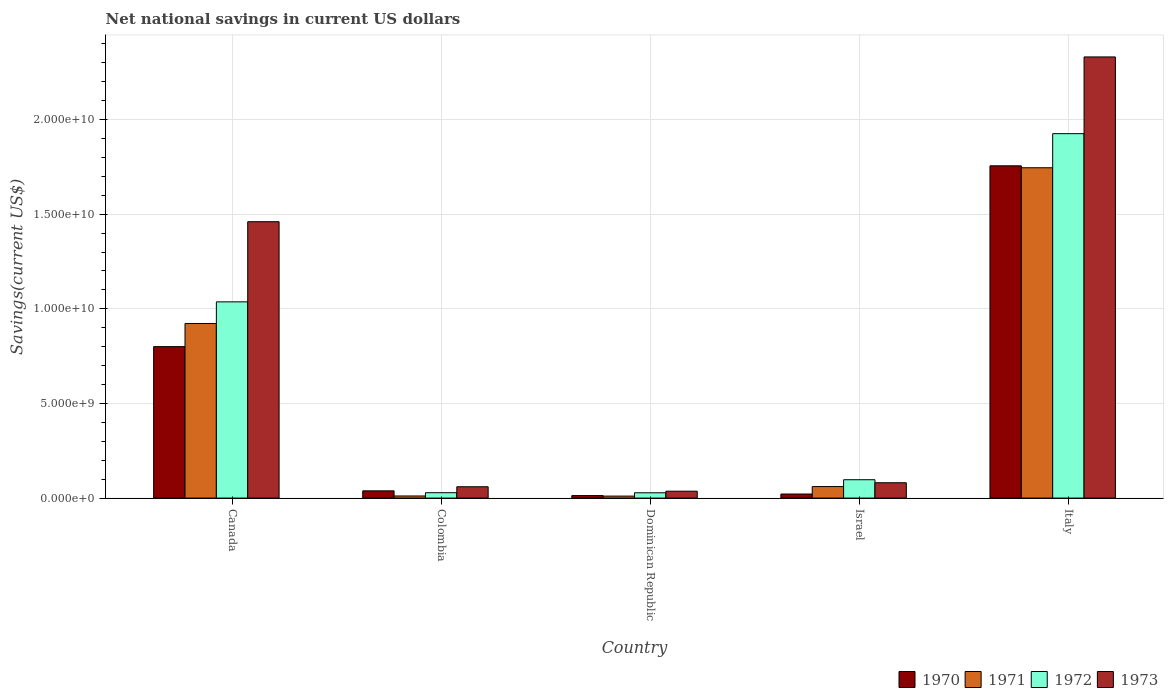How many different coloured bars are there?
Provide a short and direct response. 4. How many groups of bars are there?
Give a very brief answer. 5. Are the number of bars per tick equal to the number of legend labels?
Provide a short and direct response. Yes. How many bars are there on the 1st tick from the left?
Your response must be concise. 4. What is the label of the 4th group of bars from the left?
Make the answer very short. Israel. In how many cases, is the number of bars for a given country not equal to the number of legend labels?
Offer a terse response. 0. What is the net national savings in 1970 in Canada?
Your answer should be compact. 8.00e+09. Across all countries, what is the maximum net national savings in 1972?
Keep it short and to the point. 1.93e+1. Across all countries, what is the minimum net national savings in 1972?
Provide a short and direct response. 2.80e+08. In which country was the net national savings in 1971 maximum?
Your response must be concise. Italy. In which country was the net national savings in 1972 minimum?
Make the answer very short. Dominican Republic. What is the total net national savings in 1973 in the graph?
Your answer should be very brief. 3.97e+1. What is the difference between the net national savings in 1972 in Colombia and that in Dominican Republic?
Your response must be concise. 3.48e+06. What is the difference between the net national savings in 1972 in Colombia and the net national savings in 1970 in Italy?
Provide a short and direct response. -1.73e+1. What is the average net national savings in 1973 per country?
Offer a terse response. 7.94e+09. What is the difference between the net national savings of/in 1973 and net national savings of/in 1970 in Canada?
Ensure brevity in your answer.  6.60e+09. What is the ratio of the net national savings in 1971 in Dominican Republic to that in Italy?
Provide a succinct answer. 0.01. What is the difference between the highest and the second highest net national savings in 1972?
Offer a terse response. -1.83e+1. What is the difference between the highest and the lowest net national savings in 1970?
Ensure brevity in your answer.  1.74e+1. Is it the case that in every country, the sum of the net national savings in 1970 and net national savings in 1971 is greater than the sum of net national savings in 1972 and net national savings in 1973?
Provide a short and direct response. No. What does the 1st bar from the left in Dominican Republic represents?
Provide a succinct answer. 1970. Are the values on the major ticks of Y-axis written in scientific E-notation?
Your answer should be very brief. Yes. Does the graph contain grids?
Provide a succinct answer. Yes. Where does the legend appear in the graph?
Your answer should be very brief. Bottom right. How are the legend labels stacked?
Offer a terse response. Horizontal. What is the title of the graph?
Ensure brevity in your answer.  Net national savings in current US dollars. What is the label or title of the Y-axis?
Provide a succinct answer. Savings(current US$). What is the Savings(current US$) in 1970 in Canada?
Offer a terse response. 8.00e+09. What is the Savings(current US$) in 1971 in Canada?
Your answer should be very brief. 9.23e+09. What is the Savings(current US$) in 1972 in Canada?
Provide a succinct answer. 1.04e+1. What is the Savings(current US$) of 1973 in Canada?
Provide a succinct answer. 1.46e+1. What is the Savings(current US$) of 1970 in Colombia?
Your answer should be compact. 3.83e+08. What is the Savings(current US$) in 1971 in Colombia?
Ensure brevity in your answer.  1.11e+08. What is the Savings(current US$) of 1972 in Colombia?
Keep it short and to the point. 2.84e+08. What is the Savings(current US$) of 1973 in Colombia?
Your answer should be very brief. 5.98e+08. What is the Savings(current US$) in 1970 in Dominican Republic?
Your response must be concise. 1.33e+08. What is the Savings(current US$) in 1971 in Dominican Republic?
Provide a succinct answer. 1.05e+08. What is the Savings(current US$) of 1972 in Dominican Republic?
Your response must be concise. 2.80e+08. What is the Savings(current US$) in 1973 in Dominican Republic?
Keep it short and to the point. 3.65e+08. What is the Savings(current US$) of 1970 in Israel?
Keep it short and to the point. 2.15e+08. What is the Savings(current US$) of 1971 in Israel?
Keep it short and to the point. 6.09e+08. What is the Savings(current US$) of 1972 in Israel?
Make the answer very short. 9.71e+08. What is the Savings(current US$) of 1973 in Israel?
Your response must be concise. 8.11e+08. What is the Savings(current US$) in 1970 in Italy?
Provide a short and direct response. 1.76e+1. What is the Savings(current US$) of 1971 in Italy?
Give a very brief answer. 1.75e+1. What is the Savings(current US$) in 1972 in Italy?
Provide a succinct answer. 1.93e+1. What is the Savings(current US$) of 1973 in Italy?
Give a very brief answer. 2.33e+1. Across all countries, what is the maximum Savings(current US$) of 1970?
Offer a very short reply. 1.76e+1. Across all countries, what is the maximum Savings(current US$) in 1971?
Make the answer very short. 1.75e+1. Across all countries, what is the maximum Savings(current US$) in 1972?
Make the answer very short. 1.93e+1. Across all countries, what is the maximum Savings(current US$) in 1973?
Offer a very short reply. 2.33e+1. Across all countries, what is the minimum Savings(current US$) in 1970?
Your answer should be very brief. 1.33e+08. Across all countries, what is the minimum Savings(current US$) of 1971?
Your answer should be very brief. 1.05e+08. Across all countries, what is the minimum Savings(current US$) of 1972?
Keep it short and to the point. 2.80e+08. Across all countries, what is the minimum Savings(current US$) in 1973?
Provide a succinct answer. 3.65e+08. What is the total Savings(current US$) of 1970 in the graph?
Give a very brief answer. 2.63e+1. What is the total Savings(current US$) of 1971 in the graph?
Provide a succinct answer. 2.75e+1. What is the total Savings(current US$) of 1972 in the graph?
Your response must be concise. 3.12e+1. What is the total Savings(current US$) in 1973 in the graph?
Your answer should be very brief. 3.97e+1. What is the difference between the Savings(current US$) in 1970 in Canada and that in Colombia?
Your answer should be compact. 7.62e+09. What is the difference between the Savings(current US$) of 1971 in Canada and that in Colombia?
Provide a succinct answer. 9.11e+09. What is the difference between the Savings(current US$) in 1972 in Canada and that in Colombia?
Make the answer very short. 1.01e+1. What is the difference between the Savings(current US$) in 1973 in Canada and that in Colombia?
Ensure brevity in your answer.  1.40e+1. What is the difference between the Savings(current US$) of 1970 in Canada and that in Dominican Republic?
Ensure brevity in your answer.  7.87e+09. What is the difference between the Savings(current US$) of 1971 in Canada and that in Dominican Republic?
Provide a succinct answer. 9.12e+09. What is the difference between the Savings(current US$) in 1972 in Canada and that in Dominican Republic?
Provide a succinct answer. 1.01e+1. What is the difference between the Savings(current US$) of 1973 in Canada and that in Dominican Republic?
Your answer should be compact. 1.42e+1. What is the difference between the Savings(current US$) of 1970 in Canada and that in Israel?
Your response must be concise. 7.79e+09. What is the difference between the Savings(current US$) in 1971 in Canada and that in Israel?
Offer a very short reply. 8.62e+09. What is the difference between the Savings(current US$) of 1972 in Canada and that in Israel?
Provide a succinct answer. 9.40e+09. What is the difference between the Savings(current US$) of 1973 in Canada and that in Israel?
Your answer should be very brief. 1.38e+1. What is the difference between the Savings(current US$) in 1970 in Canada and that in Italy?
Make the answer very short. -9.55e+09. What is the difference between the Savings(current US$) in 1971 in Canada and that in Italy?
Provide a succinct answer. -8.23e+09. What is the difference between the Savings(current US$) of 1972 in Canada and that in Italy?
Make the answer very short. -8.89e+09. What is the difference between the Savings(current US$) of 1973 in Canada and that in Italy?
Your answer should be very brief. -8.71e+09. What is the difference between the Savings(current US$) in 1970 in Colombia and that in Dominican Republic?
Ensure brevity in your answer.  2.50e+08. What is the difference between the Savings(current US$) in 1971 in Colombia and that in Dominican Republic?
Your answer should be very brief. 6.03e+06. What is the difference between the Savings(current US$) of 1972 in Colombia and that in Dominican Republic?
Offer a terse response. 3.48e+06. What is the difference between the Savings(current US$) in 1973 in Colombia and that in Dominican Republic?
Provide a succinct answer. 2.34e+08. What is the difference between the Savings(current US$) of 1970 in Colombia and that in Israel?
Keep it short and to the point. 1.68e+08. What is the difference between the Savings(current US$) of 1971 in Colombia and that in Israel?
Offer a terse response. -4.97e+08. What is the difference between the Savings(current US$) in 1972 in Colombia and that in Israel?
Your response must be concise. -6.87e+08. What is the difference between the Savings(current US$) of 1973 in Colombia and that in Israel?
Provide a short and direct response. -2.12e+08. What is the difference between the Savings(current US$) in 1970 in Colombia and that in Italy?
Give a very brief answer. -1.72e+1. What is the difference between the Savings(current US$) in 1971 in Colombia and that in Italy?
Offer a very short reply. -1.73e+1. What is the difference between the Savings(current US$) of 1972 in Colombia and that in Italy?
Your response must be concise. -1.90e+1. What is the difference between the Savings(current US$) in 1973 in Colombia and that in Italy?
Offer a very short reply. -2.27e+1. What is the difference between the Savings(current US$) of 1970 in Dominican Republic and that in Israel?
Provide a short and direct response. -8.19e+07. What is the difference between the Savings(current US$) in 1971 in Dominican Republic and that in Israel?
Ensure brevity in your answer.  -5.03e+08. What is the difference between the Savings(current US$) in 1972 in Dominican Republic and that in Israel?
Make the answer very short. -6.90e+08. What is the difference between the Savings(current US$) of 1973 in Dominican Republic and that in Israel?
Keep it short and to the point. -4.46e+08. What is the difference between the Savings(current US$) of 1970 in Dominican Republic and that in Italy?
Provide a succinct answer. -1.74e+1. What is the difference between the Savings(current US$) of 1971 in Dominican Republic and that in Italy?
Offer a terse response. -1.73e+1. What is the difference between the Savings(current US$) of 1972 in Dominican Republic and that in Italy?
Offer a very short reply. -1.90e+1. What is the difference between the Savings(current US$) in 1973 in Dominican Republic and that in Italy?
Your answer should be compact. -2.29e+1. What is the difference between the Savings(current US$) in 1970 in Israel and that in Italy?
Keep it short and to the point. -1.73e+1. What is the difference between the Savings(current US$) of 1971 in Israel and that in Italy?
Offer a very short reply. -1.68e+1. What is the difference between the Savings(current US$) in 1972 in Israel and that in Italy?
Your response must be concise. -1.83e+1. What is the difference between the Savings(current US$) in 1973 in Israel and that in Italy?
Ensure brevity in your answer.  -2.25e+1. What is the difference between the Savings(current US$) of 1970 in Canada and the Savings(current US$) of 1971 in Colombia?
Your answer should be very brief. 7.89e+09. What is the difference between the Savings(current US$) of 1970 in Canada and the Savings(current US$) of 1972 in Colombia?
Ensure brevity in your answer.  7.72e+09. What is the difference between the Savings(current US$) in 1970 in Canada and the Savings(current US$) in 1973 in Colombia?
Offer a terse response. 7.40e+09. What is the difference between the Savings(current US$) in 1971 in Canada and the Savings(current US$) in 1972 in Colombia?
Provide a short and direct response. 8.94e+09. What is the difference between the Savings(current US$) of 1971 in Canada and the Savings(current US$) of 1973 in Colombia?
Offer a very short reply. 8.63e+09. What is the difference between the Savings(current US$) of 1972 in Canada and the Savings(current US$) of 1973 in Colombia?
Your answer should be compact. 9.77e+09. What is the difference between the Savings(current US$) in 1970 in Canada and the Savings(current US$) in 1971 in Dominican Republic?
Your answer should be very brief. 7.90e+09. What is the difference between the Savings(current US$) of 1970 in Canada and the Savings(current US$) of 1972 in Dominican Republic?
Give a very brief answer. 7.72e+09. What is the difference between the Savings(current US$) of 1970 in Canada and the Savings(current US$) of 1973 in Dominican Republic?
Offer a terse response. 7.64e+09. What is the difference between the Savings(current US$) of 1971 in Canada and the Savings(current US$) of 1972 in Dominican Republic?
Your answer should be compact. 8.94e+09. What is the difference between the Savings(current US$) of 1971 in Canada and the Savings(current US$) of 1973 in Dominican Republic?
Offer a very short reply. 8.86e+09. What is the difference between the Savings(current US$) of 1972 in Canada and the Savings(current US$) of 1973 in Dominican Republic?
Give a very brief answer. 1.00e+1. What is the difference between the Savings(current US$) of 1970 in Canada and the Savings(current US$) of 1971 in Israel?
Ensure brevity in your answer.  7.39e+09. What is the difference between the Savings(current US$) of 1970 in Canada and the Savings(current US$) of 1972 in Israel?
Your answer should be compact. 7.03e+09. What is the difference between the Savings(current US$) of 1970 in Canada and the Savings(current US$) of 1973 in Israel?
Make the answer very short. 7.19e+09. What is the difference between the Savings(current US$) of 1971 in Canada and the Savings(current US$) of 1972 in Israel?
Your answer should be compact. 8.25e+09. What is the difference between the Savings(current US$) in 1971 in Canada and the Savings(current US$) in 1973 in Israel?
Keep it short and to the point. 8.41e+09. What is the difference between the Savings(current US$) of 1972 in Canada and the Savings(current US$) of 1973 in Israel?
Provide a succinct answer. 9.56e+09. What is the difference between the Savings(current US$) in 1970 in Canada and the Savings(current US$) in 1971 in Italy?
Offer a very short reply. -9.45e+09. What is the difference between the Savings(current US$) of 1970 in Canada and the Savings(current US$) of 1972 in Italy?
Give a very brief answer. -1.13e+1. What is the difference between the Savings(current US$) of 1970 in Canada and the Savings(current US$) of 1973 in Italy?
Offer a terse response. -1.53e+1. What is the difference between the Savings(current US$) in 1971 in Canada and the Savings(current US$) in 1972 in Italy?
Offer a terse response. -1.00e+1. What is the difference between the Savings(current US$) of 1971 in Canada and the Savings(current US$) of 1973 in Italy?
Your answer should be compact. -1.41e+1. What is the difference between the Savings(current US$) in 1972 in Canada and the Savings(current US$) in 1973 in Italy?
Make the answer very short. -1.29e+1. What is the difference between the Savings(current US$) in 1970 in Colombia and the Savings(current US$) in 1971 in Dominican Republic?
Your answer should be compact. 2.77e+08. What is the difference between the Savings(current US$) of 1970 in Colombia and the Savings(current US$) of 1972 in Dominican Republic?
Provide a succinct answer. 1.02e+08. What is the difference between the Savings(current US$) of 1970 in Colombia and the Savings(current US$) of 1973 in Dominican Republic?
Your response must be concise. 1.82e+07. What is the difference between the Savings(current US$) in 1971 in Colombia and the Savings(current US$) in 1972 in Dominican Republic?
Offer a very short reply. -1.69e+08. What is the difference between the Savings(current US$) in 1971 in Colombia and the Savings(current US$) in 1973 in Dominican Republic?
Keep it short and to the point. -2.53e+08. What is the difference between the Savings(current US$) in 1972 in Colombia and the Savings(current US$) in 1973 in Dominican Republic?
Make the answer very short. -8.05e+07. What is the difference between the Savings(current US$) of 1970 in Colombia and the Savings(current US$) of 1971 in Israel?
Give a very brief answer. -2.26e+08. What is the difference between the Savings(current US$) in 1970 in Colombia and the Savings(current US$) in 1972 in Israel?
Provide a succinct answer. -5.88e+08. What is the difference between the Savings(current US$) of 1970 in Colombia and the Savings(current US$) of 1973 in Israel?
Keep it short and to the point. -4.28e+08. What is the difference between the Savings(current US$) of 1971 in Colombia and the Savings(current US$) of 1972 in Israel?
Your response must be concise. -8.59e+08. What is the difference between the Savings(current US$) in 1971 in Colombia and the Savings(current US$) in 1973 in Israel?
Provide a succinct answer. -6.99e+08. What is the difference between the Savings(current US$) of 1972 in Colombia and the Savings(current US$) of 1973 in Israel?
Offer a terse response. -5.27e+08. What is the difference between the Savings(current US$) in 1970 in Colombia and the Savings(current US$) in 1971 in Italy?
Provide a short and direct response. -1.71e+1. What is the difference between the Savings(current US$) in 1970 in Colombia and the Savings(current US$) in 1972 in Italy?
Ensure brevity in your answer.  -1.89e+1. What is the difference between the Savings(current US$) in 1970 in Colombia and the Savings(current US$) in 1973 in Italy?
Keep it short and to the point. -2.29e+1. What is the difference between the Savings(current US$) in 1971 in Colombia and the Savings(current US$) in 1972 in Italy?
Keep it short and to the point. -1.91e+1. What is the difference between the Savings(current US$) of 1971 in Colombia and the Savings(current US$) of 1973 in Italy?
Offer a terse response. -2.32e+1. What is the difference between the Savings(current US$) in 1972 in Colombia and the Savings(current US$) in 1973 in Italy?
Keep it short and to the point. -2.30e+1. What is the difference between the Savings(current US$) in 1970 in Dominican Republic and the Savings(current US$) in 1971 in Israel?
Your response must be concise. -4.76e+08. What is the difference between the Savings(current US$) in 1970 in Dominican Republic and the Savings(current US$) in 1972 in Israel?
Your response must be concise. -8.38e+08. What is the difference between the Savings(current US$) of 1970 in Dominican Republic and the Savings(current US$) of 1973 in Israel?
Make the answer very short. -6.78e+08. What is the difference between the Savings(current US$) of 1971 in Dominican Republic and the Savings(current US$) of 1972 in Israel?
Provide a succinct answer. -8.65e+08. What is the difference between the Savings(current US$) of 1971 in Dominican Republic and the Savings(current US$) of 1973 in Israel?
Make the answer very short. -7.05e+08. What is the difference between the Savings(current US$) of 1972 in Dominican Republic and the Savings(current US$) of 1973 in Israel?
Give a very brief answer. -5.30e+08. What is the difference between the Savings(current US$) of 1970 in Dominican Republic and the Savings(current US$) of 1971 in Italy?
Offer a terse response. -1.73e+1. What is the difference between the Savings(current US$) in 1970 in Dominican Republic and the Savings(current US$) in 1972 in Italy?
Make the answer very short. -1.91e+1. What is the difference between the Savings(current US$) in 1970 in Dominican Republic and the Savings(current US$) in 1973 in Italy?
Provide a succinct answer. -2.32e+1. What is the difference between the Savings(current US$) in 1971 in Dominican Republic and the Savings(current US$) in 1972 in Italy?
Keep it short and to the point. -1.91e+1. What is the difference between the Savings(current US$) in 1971 in Dominican Republic and the Savings(current US$) in 1973 in Italy?
Offer a very short reply. -2.32e+1. What is the difference between the Savings(current US$) in 1972 in Dominican Republic and the Savings(current US$) in 1973 in Italy?
Your answer should be very brief. -2.30e+1. What is the difference between the Savings(current US$) of 1970 in Israel and the Savings(current US$) of 1971 in Italy?
Your answer should be very brief. -1.72e+1. What is the difference between the Savings(current US$) of 1970 in Israel and the Savings(current US$) of 1972 in Italy?
Offer a very short reply. -1.90e+1. What is the difference between the Savings(current US$) in 1970 in Israel and the Savings(current US$) in 1973 in Italy?
Provide a succinct answer. -2.31e+1. What is the difference between the Savings(current US$) in 1971 in Israel and the Savings(current US$) in 1972 in Italy?
Your answer should be compact. -1.86e+1. What is the difference between the Savings(current US$) in 1971 in Israel and the Savings(current US$) in 1973 in Italy?
Your answer should be compact. -2.27e+1. What is the difference between the Savings(current US$) in 1972 in Israel and the Savings(current US$) in 1973 in Italy?
Provide a short and direct response. -2.23e+1. What is the average Savings(current US$) of 1970 per country?
Give a very brief answer. 5.26e+09. What is the average Savings(current US$) of 1971 per country?
Provide a succinct answer. 5.50e+09. What is the average Savings(current US$) in 1972 per country?
Keep it short and to the point. 6.23e+09. What is the average Savings(current US$) in 1973 per country?
Offer a terse response. 7.94e+09. What is the difference between the Savings(current US$) of 1970 and Savings(current US$) of 1971 in Canada?
Your response must be concise. -1.22e+09. What is the difference between the Savings(current US$) in 1970 and Savings(current US$) in 1972 in Canada?
Keep it short and to the point. -2.37e+09. What is the difference between the Savings(current US$) of 1970 and Savings(current US$) of 1973 in Canada?
Your answer should be very brief. -6.60e+09. What is the difference between the Savings(current US$) of 1971 and Savings(current US$) of 1972 in Canada?
Give a very brief answer. -1.14e+09. What is the difference between the Savings(current US$) in 1971 and Savings(current US$) in 1973 in Canada?
Give a very brief answer. -5.38e+09. What is the difference between the Savings(current US$) in 1972 and Savings(current US$) in 1973 in Canada?
Give a very brief answer. -4.23e+09. What is the difference between the Savings(current US$) in 1970 and Savings(current US$) in 1971 in Colombia?
Keep it short and to the point. 2.71e+08. What is the difference between the Savings(current US$) of 1970 and Savings(current US$) of 1972 in Colombia?
Provide a short and direct response. 9.87e+07. What is the difference between the Savings(current US$) of 1970 and Savings(current US$) of 1973 in Colombia?
Make the answer very short. -2.16e+08. What is the difference between the Savings(current US$) of 1971 and Savings(current US$) of 1972 in Colombia?
Keep it short and to the point. -1.73e+08. What is the difference between the Savings(current US$) of 1971 and Savings(current US$) of 1973 in Colombia?
Offer a very short reply. -4.87e+08. What is the difference between the Savings(current US$) of 1972 and Savings(current US$) of 1973 in Colombia?
Give a very brief answer. -3.14e+08. What is the difference between the Savings(current US$) of 1970 and Savings(current US$) of 1971 in Dominican Republic?
Your response must be concise. 2.74e+07. What is the difference between the Savings(current US$) of 1970 and Savings(current US$) of 1972 in Dominican Republic?
Ensure brevity in your answer.  -1.48e+08. What is the difference between the Savings(current US$) of 1970 and Savings(current US$) of 1973 in Dominican Republic?
Your answer should be very brief. -2.32e+08. What is the difference between the Savings(current US$) in 1971 and Savings(current US$) in 1972 in Dominican Republic?
Offer a terse response. -1.75e+08. What is the difference between the Savings(current US$) of 1971 and Savings(current US$) of 1973 in Dominican Republic?
Your answer should be very brief. -2.59e+08. What is the difference between the Savings(current US$) in 1972 and Savings(current US$) in 1973 in Dominican Republic?
Offer a terse response. -8.40e+07. What is the difference between the Savings(current US$) of 1970 and Savings(current US$) of 1971 in Israel?
Offer a very short reply. -3.94e+08. What is the difference between the Savings(current US$) of 1970 and Savings(current US$) of 1972 in Israel?
Provide a short and direct response. -7.56e+08. What is the difference between the Savings(current US$) of 1970 and Savings(current US$) of 1973 in Israel?
Your response must be concise. -5.96e+08. What is the difference between the Savings(current US$) of 1971 and Savings(current US$) of 1972 in Israel?
Give a very brief answer. -3.62e+08. What is the difference between the Savings(current US$) of 1971 and Savings(current US$) of 1973 in Israel?
Offer a terse response. -2.02e+08. What is the difference between the Savings(current US$) of 1972 and Savings(current US$) of 1973 in Israel?
Give a very brief answer. 1.60e+08. What is the difference between the Savings(current US$) of 1970 and Savings(current US$) of 1971 in Italy?
Make the answer very short. 1.03e+08. What is the difference between the Savings(current US$) in 1970 and Savings(current US$) in 1972 in Italy?
Your answer should be compact. -1.70e+09. What is the difference between the Savings(current US$) in 1970 and Savings(current US$) in 1973 in Italy?
Provide a short and direct response. -5.75e+09. What is the difference between the Savings(current US$) in 1971 and Savings(current US$) in 1972 in Italy?
Ensure brevity in your answer.  -1.80e+09. What is the difference between the Savings(current US$) in 1971 and Savings(current US$) in 1973 in Italy?
Make the answer very short. -5.86e+09. What is the difference between the Savings(current US$) in 1972 and Savings(current US$) in 1973 in Italy?
Provide a succinct answer. -4.05e+09. What is the ratio of the Savings(current US$) of 1970 in Canada to that in Colombia?
Your response must be concise. 20.91. What is the ratio of the Savings(current US$) of 1971 in Canada to that in Colombia?
Your answer should be compact. 82.79. What is the ratio of the Savings(current US$) in 1972 in Canada to that in Colombia?
Provide a short and direct response. 36.51. What is the ratio of the Savings(current US$) in 1973 in Canada to that in Colombia?
Provide a succinct answer. 24.4. What is the ratio of the Savings(current US$) in 1970 in Canada to that in Dominican Republic?
Give a very brief answer. 60.27. What is the ratio of the Savings(current US$) of 1971 in Canada to that in Dominican Republic?
Provide a succinct answer. 87.52. What is the ratio of the Savings(current US$) of 1972 in Canada to that in Dominican Republic?
Ensure brevity in your answer.  36.96. What is the ratio of the Savings(current US$) in 1973 in Canada to that in Dominican Republic?
Your answer should be very brief. 40.06. What is the ratio of the Savings(current US$) in 1970 in Canada to that in Israel?
Provide a short and direct response. 37.28. What is the ratio of the Savings(current US$) in 1971 in Canada to that in Israel?
Offer a terse response. 15.16. What is the ratio of the Savings(current US$) of 1972 in Canada to that in Israel?
Your answer should be compact. 10.68. What is the ratio of the Savings(current US$) of 1973 in Canada to that in Israel?
Ensure brevity in your answer.  18.01. What is the ratio of the Savings(current US$) in 1970 in Canada to that in Italy?
Your answer should be very brief. 0.46. What is the ratio of the Savings(current US$) of 1971 in Canada to that in Italy?
Provide a short and direct response. 0.53. What is the ratio of the Savings(current US$) in 1972 in Canada to that in Italy?
Your answer should be compact. 0.54. What is the ratio of the Savings(current US$) of 1973 in Canada to that in Italy?
Provide a succinct answer. 0.63. What is the ratio of the Savings(current US$) in 1970 in Colombia to that in Dominican Republic?
Keep it short and to the point. 2.88. What is the ratio of the Savings(current US$) of 1971 in Colombia to that in Dominican Republic?
Offer a terse response. 1.06. What is the ratio of the Savings(current US$) in 1972 in Colombia to that in Dominican Republic?
Provide a short and direct response. 1.01. What is the ratio of the Savings(current US$) of 1973 in Colombia to that in Dominican Republic?
Your answer should be very brief. 1.64. What is the ratio of the Savings(current US$) of 1970 in Colombia to that in Israel?
Ensure brevity in your answer.  1.78. What is the ratio of the Savings(current US$) of 1971 in Colombia to that in Israel?
Keep it short and to the point. 0.18. What is the ratio of the Savings(current US$) in 1972 in Colombia to that in Israel?
Give a very brief answer. 0.29. What is the ratio of the Savings(current US$) of 1973 in Colombia to that in Israel?
Ensure brevity in your answer.  0.74. What is the ratio of the Savings(current US$) of 1970 in Colombia to that in Italy?
Your response must be concise. 0.02. What is the ratio of the Savings(current US$) in 1971 in Colombia to that in Italy?
Offer a terse response. 0.01. What is the ratio of the Savings(current US$) of 1972 in Colombia to that in Italy?
Give a very brief answer. 0.01. What is the ratio of the Savings(current US$) in 1973 in Colombia to that in Italy?
Provide a short and direct response. 0.03. What is the ratio of the Savings(current US$) in 1970 in Dominican Republic to that in Israel?
Your response must be concise. 0.62. What is the ratio of the Savings(current US$) in 1971 in Dominican Republic to that in Israel?
Ensure brevity in your answer.  0.17. What is the ratio of the Savings(current US$) of 1972 in Dominican Republic to that in Israel?
Provide a succinct answer. 0.29. What is the ratio of the Savings(current US$) of 1973 in Dominican Republic to that in Israel?
Ensure brevity in your answer.  0.45. What is the ratio of the Savings(current US$) in 1970 in Dominican Republic to that in Italy?
Make the answer very short. 0.01. What is the ratio of the Savings(current US$) in 1971 in Dominican Republic to that in Italy?
Your answer should be very brief. 0.01. What is the ratio of the Savings(current US$) of 1972 in Dominican Republic to that in Italy?
Ensure brevity in your answer.  0.01. What is the ratio of the Savings(current US$) of 1973 in Dominican Republic to that in Italy?
Provide a short and direct response. 0.02. What is the ratio of the Savings(current US$) in 1970 in Israel to that in Italy?
Make the answer very short. 0.01. What is the ratio of the Savings(current US$) in 1971 in Israel to that in Italy?
Offer a terse response. 0.03. What is the ratio of the Savings(current US$) in 1972 in Israel to that in Italy?
Make the answer very short. 0.05. What is the ratio of the Savings(current US$) in 1973 in Israel to that in Italy?
Keep it short and to the point. 0.03. What is the difference between the highest and the second highest Savings(current US$) of 1970?
Make the answer very short. 9.55e+09. What is the difference between the highest and the second highest Savings(current US$) in 1971?
Give a very brief answer. 8.23e+09. What is the difference between the highest and the second highest Savings(current US$) in 1972?
Provide a short and direct response. 8.89e+09. What is the difference between the highest and the second highest Savings(current US$) in 1973?
Your answer should be compact. 8.71e+09. What is the difference between the highest and the lowest Savings(current US$) in 1970?
Give a very brief answer. 1.74e+1. What is the difference between the highest and the lowest Savings(current US$) of 1971?
Keep it short and to the point. 1.73e+1. What is the difference between the highest and the lowest Savings(current US$) in 1972?
Provide a succinct answer. 1.90e+1. What is the difference between the highest and the lowest Savings(current US$) of 1973?
Provide a succinct answer. 2.29e+1. 